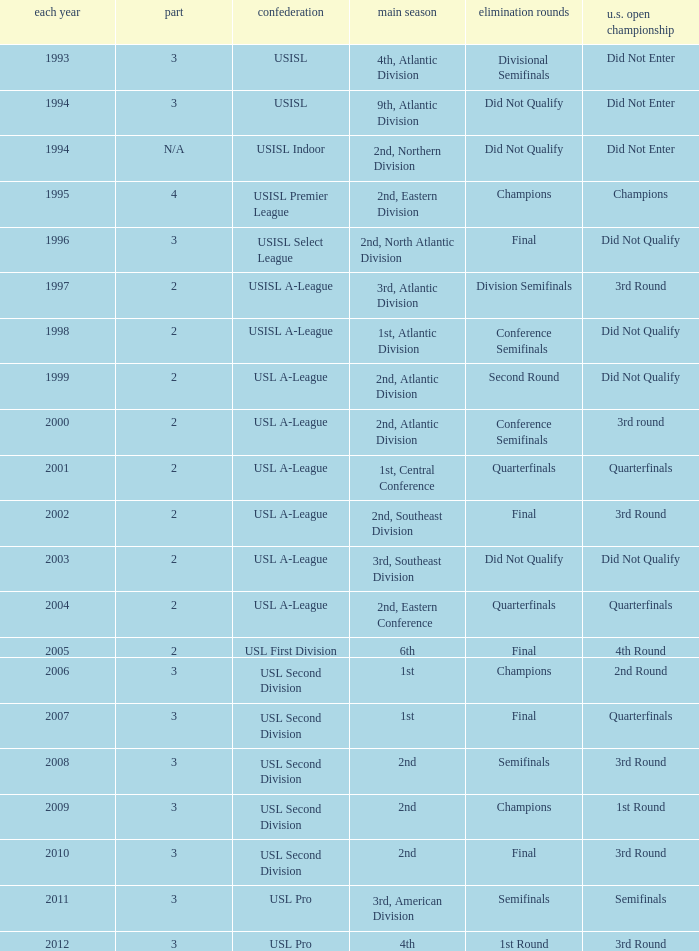What's the u.s. open cup status for regular season of 4th, atlantic division  Did Not Enter. 